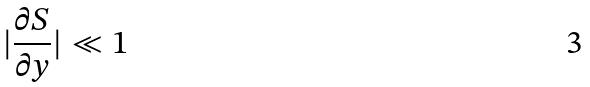<formula> <loc_0><loc_0><loc_500><loc_500>| \frac { \partial S } { \partial y } | \ll 1</formula> 